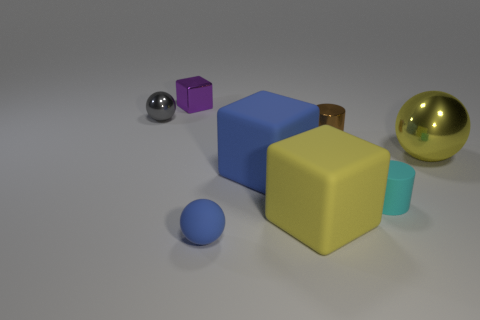The gray sphere is what size?
Keep it short and to the point. Small. How many things are either purple cylinders or big blue rubber objects that are behind the small rubber ball?
Your answer should be very brief. 1. How many other objects are there of the same color as the rubber cylinder?
Your answer should be compact. 0. Is the size of the cyan thing the same as the block that is behind the blue block?
Offer a terse response. Yes. Do the rubber thing that is on the right side of the yellow rubber block and the yellow ball have the same size?
Make the answer very short. No. How many other things are there of the same material as the tiny blue sphere?
Offer a terse response. 3. Are there the same number of small blue matte balls that are to the right of the big yellow rubber object and small shiny cubes behind the tiny gray thing?
Give a very brief answer. No. What color is the thing that is to the left of the tiny metal object that is behind the metallic ball to the left of the yellow metal sphere?
Offer a very short reply. Gray. What shape is the big yellow object that is to the left of the yellow sphere?
Your answer should be very brief. Cube. There is a big blue object that is the same material as the cyan cylinder; what shape is it?
Your answer should be compact. Cube. 